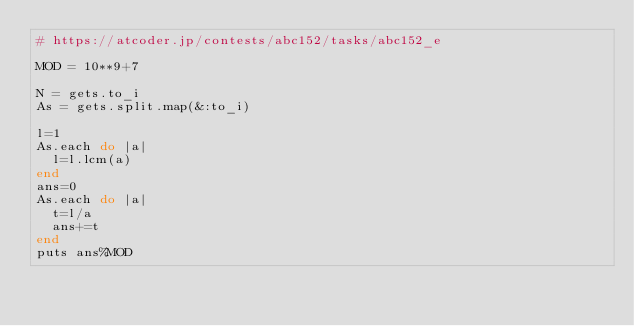<code> <loc_0><loc_0><loc_500><loc_500><_Ruby_># https://atcoder.jp/contests/abc152/tasks/abc152_e

MOD = 10**9+7

N = gets.to_i
As = gets.split.map(&:to_i)

l=1
As.each do |a|
  l=l.lcm(a)
end
ans=0
As.each do |a|
  t=l/a
  ans+=t
end
puts ans%MOD
</code> 